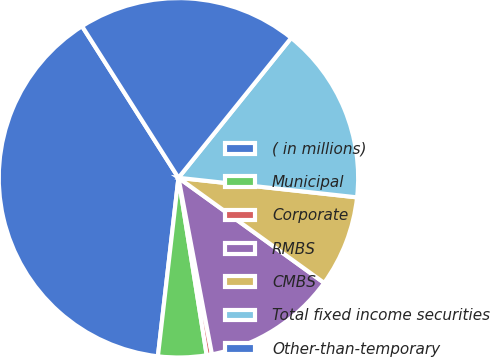Convert chart to OTSL. <chart><loc_0><loc_0><loc_500><loc_500><pie_chart><fcel>( in millions)<fcel>Municipal<fcel>Corporate<fcel>RMBS<fcel>CMBS<fcel>Total fixed income securities<fcel>Other-than-temporary<nl><fcel>39.16%<fcel>4.34%<fcel>0.47%<fcel>12.07%<fcel>8.21%<fcel>15.94%<fcel>19.81%<nl></chart> 